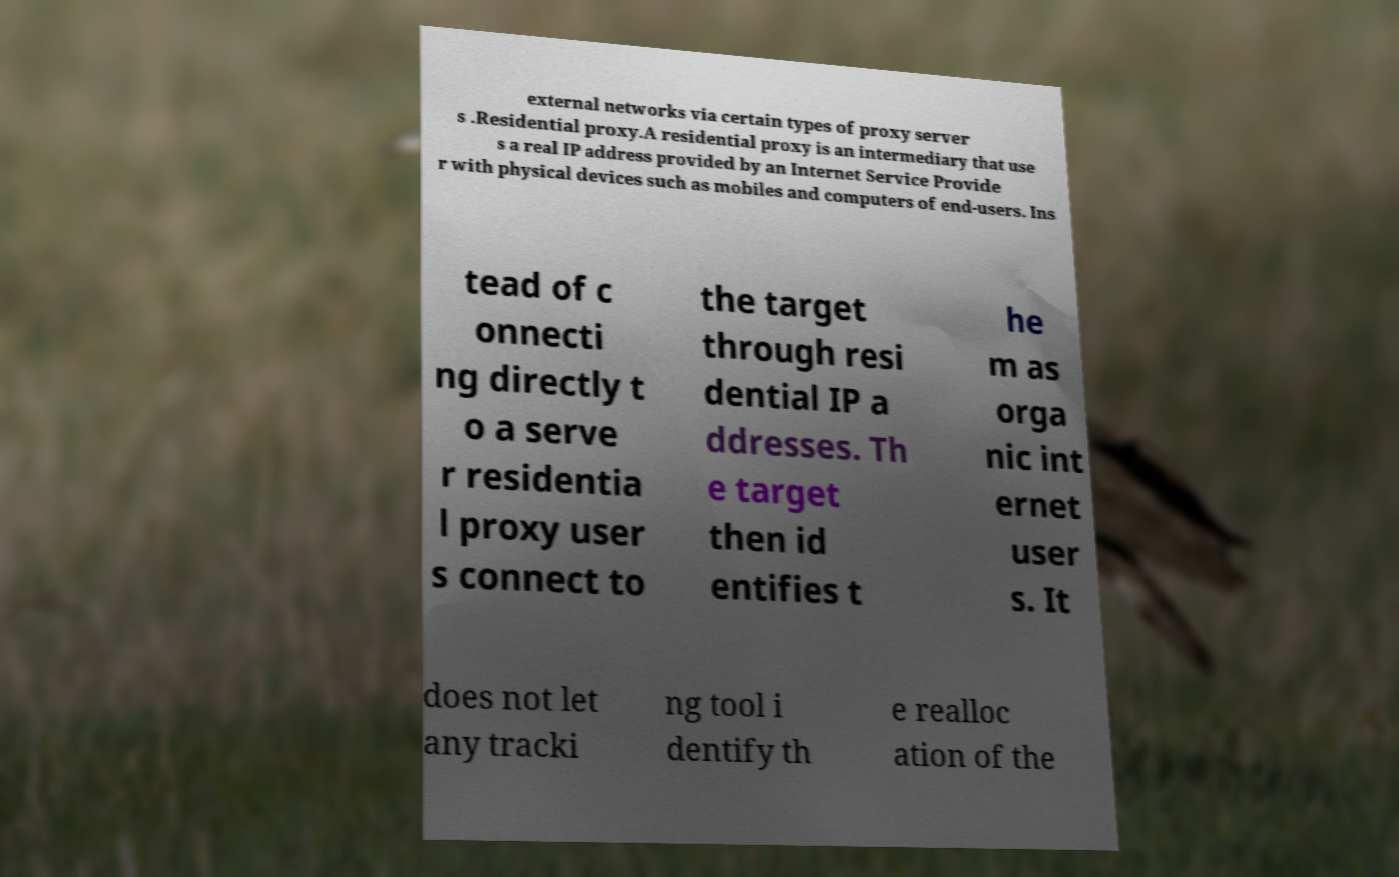For documentation purposes, I need the text within this image transcribed. Could you provide that? external networks via certain types of proxy server s .Residential proxy.A residential proxy is an intermediary that use s a real IP address provided by an Internet Service Provide r with physical devices such as mobiles and computers of end-users. Ins tead of c onnecti ng directly t o a serve r residentia l proxy user s connect to the target through resi dential IP a ddresses. Th e target then id entifies t he m as orga nic int ernet user s. It does not let any tracki ng tool i dentify th e realloc ation of the 